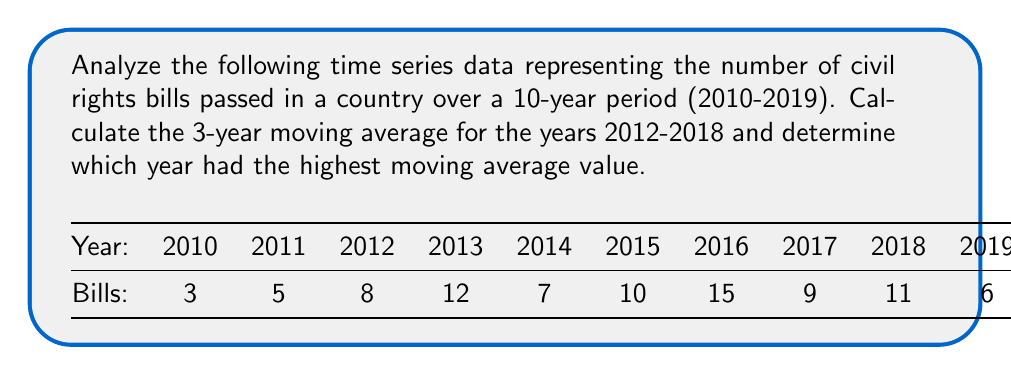Show me your answer to this math problem. To solve this problem, we need to follow these steps:

1. Calculate the 3-year moving average for each year from 2012 to 2018.
2. Compare the moving averages to find the highest value.

Step 1: Calculating 3-year moving averages

The formula for a 3-year moving average is:

$$ MA_3 = \frac{X_{t-1} + X_t + X_{t+1}}{3} $$

Where $X_t$ is the value for the current year, $X_{t-1}$ is the value for the previous year, and $X_{t+1}$ is the value for the following year.

2012: $MA_3 = \frac{5 + 8 + 12}{3} = \frac{25}{3} \approx 8.33$
2013: $MA_3 = \frac{8 + 12 + 7}{3} = 9$
2014: $MA_3 = \frac{12 + 7 + 10}{3} = \frac{29}{3} \approx 9.67$
2015: $MA_3 = \frac{7 + 10 + 15}{3} = \frac{32}{3} \approx 10.67$
2016: $MA_3 = \frac{10 + 15 + 9}{3} = \frac{34}{3} \approx 11.33$
2017: $MA_3 = \frac{15 + 9 + 11}{3} = \frac{35}{3} \approx 11.67$
2018: $MA_3 = \frac{9 + 11 + 6}{3} = \frac{26}{3} \approx 8.67$

Step 2: Comparing moving averages

The highest 3-year moving average is approximately 11.67, which occurred in 2017.
Answer: 2017 